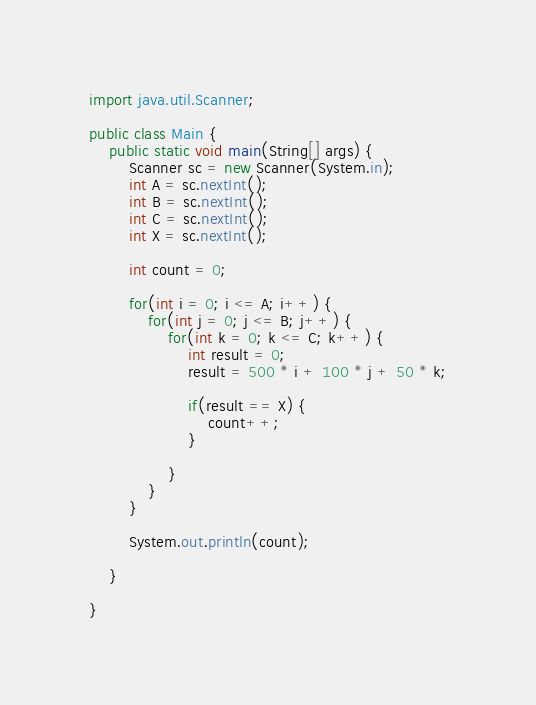Convert code to text. <code><loc_0><loc_0><loc_500><loc_500><_Java_>import java.util.Scanner;

public class Main {
	public static void main(String[] args) {
		Scanner sc = new Scanner(System.in);
		int A = sc.nextInt();
		int B = sc.nextInt();
		int C = sc.nextInt();
		int X = sc.nextInt();

		int count = 0;

		for(int i = 0; i <= A; i++) {
			for(int j = 0; j <= B; j++) {
				for(int k = 0; k <= C; k++) {
					int result = 0;
					result = 500 * i + 100 * j + 50 * k;

					if(result == X) {
						count++;
					}

				}
			}
		}

		System.out.println(count);

	}

}
</code> 